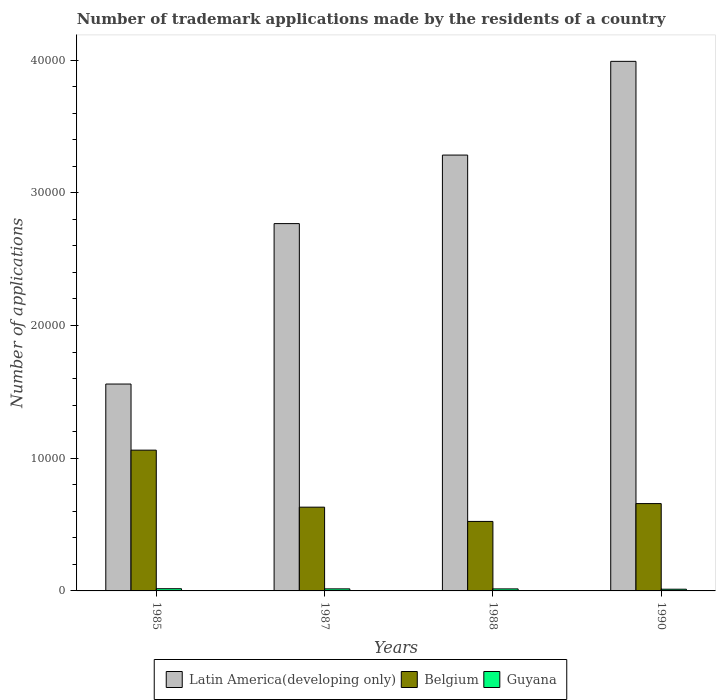Are the number of bars per tick equal to the number of legend labels?
Offer a terse response. Yes. What is the number of trademark applications made by the residents in Latin America(developing only) in 1987?
Your answer should be very brief. 2.77e+04. Across all years, what is the maximum number of trademark applications made by the residents in Latin America(developing only)?
Make the answer very short. 3.99e+04. Across all years, what is the minimum number of trademark applications made by the residents in Belgium?
Provide a short and direct response. 5237. What is the total number of trademark applications made by the residents in Guyana in the graph?
Your response must be concise. 602. What is the difference between the number of trademark applications made by the residents in Belgium in 1987 and that in 1990?
Offer a terse response. -269. What is the difference between the number of trademark applications made by the residents in Belgium in 1988 and the number of trademark applications made by the residents in Latin America(developing only) in 1987?
Offer a terse response. -2.24e+04. What is the average number of trademark applications made by the residents in Guyana per year?
Your answer should be very brief. 150.5. In the year 1990, what is the difference between the number of trademark applications made by the residents in Guyana and number of trademark applications made by the residents in Belgium?
Your response must be concise. -6452. What is the ratio of the number of trademark applications made by the residents in Latin America(developing only) in 1987 to that in 1990?
Provide a short and direct response. 0.69. Is the number of trademark applications made by the residents in Belgium in 1985 less than that in 1990?
Offer a very short reply. No. Is the difference between the number of trademark applications made by the residents in Guyana in 1987 and 1988 greater than the difference between the number of trademark applications made by the residents in Belgium in 1987 and 1988?
Your answer should be compact. No. What is the difference between the highest and the second highest number of trademark applications made by the residents in Latin America(developing only)?
Provide a short and direct response. 7062. What is the difference between the highest and the lowest number of trademark applications made by the residents in Latin America(developing only)?
Keep it short and to the point. 2.43e+04. What does the 3rd bar from the left in 1990 represents?
Your response must be concise. Guyana. What does the 1st bar from the right in 1988 represents?
Provide a succinct answer. Guyana. Is it the case that in every year, the sum of the number of trademark applications made by the residents in Latin America(developing only) and number of trademark applications made by the residents in Guyana is greater than the number of trademark applications made by the residents in Belgium?
Your answer should be very brief. Yes. Are all the bars in the graph horizontal?
Give a very brief answer. No. How many years are there in the graph?
Provide a short and direct response. 4. Are the values on the major ticks of Y-axis written in scientific E-notation?
Your response must be concise. No. How many legend labels are there?
Your answer should be very brief. 3. What is the title of the graph?
Your answer should be very brief. Number of trademark applications made by the residents of a country. Does "Timor-Leste" appear as one of the legend labels in the graph?
Offer a very short reply. No. What is the label or title of the X-axis?
Provide a succinct answer. Years. What is the label or title of the Y-axis?
Make the answer very short. Number of applications. What is the Number of applications of Latin America(developing only) in 1985?
Provide a short and direct response. 1.56e+04. What is the Number of applications in Belgium in 1985?
Ensure brevity in your answer.  1.06e+04. What is the Number of applications of Guyana in 1985?
Offer a very short reply. 166. What is the Number of applications of Latin America(developing only) in 1987?
Keep it short and to the point. 2.77e+04. What is the Number of applications in Belgium in 1987?
Keep it short and to the point. 6312. What is the Number of applications in Guyana in 1987?
Offer a terse response. 155. What is the Number of applications of Latin America(developing only) in 1988?
Your response must be concise. 3.28e+04. What is the Number of applications of Belgium in 1988?
Ensure brevity in your answer.  5237. What is the Number of applications in Guyana in 1988?
Make the answer very short. 152. What is the Number of applications in Latin America(developing only) in 1990?
Your response must be concise. 3.99e+04. What is the Number of applications in Belgium in 1990?
Ensure brevity in your answer.  6581. What is the Number of applications in Guyana in 1990?
Offer a terse response. 129. Across all years, what is the maximum Number of applications in Latin America(developing only)?
Provide a succinct answer. 3.99e+04. Across all years, what is the maximum Number of applications in Belgium?
Ensure brevity in your answer.  1.06e+04. Across all years, what is the maximum Number of applications of Guyana?
Keep it short and to the point. 166. Across all years, what is the minimum Number of applications in Latin America(developing only)?
Provide a succinct answer. 1.56e+04. Across all years, what is the minimum Number of applications of Belgium?
Offer a terse response. 5237. Across all years, what is the minimum Number of applications of Guyana?
Give a very brief answer. 129. What is the total Number of applications in Latin America(developing only) in the graph?
Your response must be concise. 1.16e+05. What is the total Number of applications of Belgium in the graph?
Give a very brief answer. 2.87e+04. What is the total Number of applications of Guyana in the graph?
Provide a short and direct response. 602. What is the difference between the Number of applications in Latin America(developing only) in 1985 and that in 1987?
Offer a very short reply. -1.21e+04. What is the difference between the Number of applications of Belgium in 1985 and that in 1987?
Your answer should be compact. 4296. What is the difference between the Number of applications of Latin America(developing only) in 1985 and that in 1988?
Provide a short and direct response. -1.73e+04. What is the difference between the Number of applications in Belgium in 1985 and that in 1988?
Make the answer very short. 5371. What is the difference between the Number of applications in Latin America(developing only) in 1985 and that in 1990?
Your answer should be compact. -2.43e+04. What is the difference between the Number of applications in Belgium in 1985 and that in 1990?
Provide a succinct answer. 4027. What is the difference between the Number of applications of Latin America(developing only) in 1987 and that in 1988?
Keep it short and to the point. -5165. What is the difference between the Number of applications in Belgium in 1987 and that in 1988?
Offer a very short reply. 1075. What is the difference between the Number of applications in Latin America(developing only) in 1987 and that in 1990?
Give a very brief answer. -1.22e+04. What is the difference between the Number of applications in Belgium in 1987 and that in 1990?
Your response must be concise. -269. What is the difference between the Number of applications in Latin America(developing only) in 1988 and that in 1990?
Provide a short and direct response. -7062. What is the difference between the Number of applications in Belgium in 1988 and that in 1990?
Offer a terse response. -1344. What is the difference between the Number of applications of Latin America(developing only) in 1985 and the Number of applications of Belgium in 1987?
Ensure brevity in your answer.  9278. What is the difference between the Number of applications in Latin America(developing only) in 1985 and the Number of applications in Guyana in 1987?
Provide a short and direct response. 1.54e+04. What is the difference between the Number of applications in Belgium in 1985 and the Number of applications in Guyana in 1987?
Ensure brevity in your answer.  1.05e+04. What is the difference between the Number of applications in Latin America(developing only) in 1985 and the Number of applications in Belgium in 1988?
Your answer should be very brief. 1.04e+04. What is the difference between the Number of applications of Latin America(developing only) in 1985 and the Number of applications of Guyana in 1988?
Give a very brief answer. 1.54e+04. What is the difference between the Number of applications of Belgium in 1985 and the Number of applications of Guyana in 1988?
Make the answer very short. 1.05e+04. What is the difference between the Number of applications of Latin America(developing only) in 1985 and the Number of applications of Belgium in 1990?
Ensure brevity in your answer.  9009. What is the difference between the Number of applications in Latin America(developing only) in 1985 and the Number of applications in Guyana in 1990?
Your answer should be very brief. 1.55e+04. What is the difference between the Number of applications of Belgium in 1985 and the Number of applications of Guyana in 1990?
Give a very brief answer. 1.05e+04. What is the difference between the Number of applications in Latin America(developing only) in 1987 and the Number of applications in Belgium in 1988?
Give a very brief answer. 2.24e+04. What is the difference between the Number of applications of Latin America(developing only) in 1987 and the Number of applications of Guyana in 1988?
Your response must be concise. 2.75e+04. What is the difference between the Number of applications in Belgium in 1987 and the Number of applications in Guyana in 1988?
Ensure brevity in your answer.  6160. What is the difference between the Number of applications of Latin America(developing only) in 1987 and the Number of applications of Belgium in 1990?
Make the answer very short. 2.11e+04. What is the difference between the Number of applications in Latin America(developing only) in 1987 and the Number of applications in Guyana in 1990?
Ensure brevity in your answer.  2.76e+04. What is the difference between the Number of applications in Belgium in 1987 and the Number of applications in Guyana in 1990?
Offer a very short reply. 6183. What is the difference between the Number of applications of Latin America(developing only) in 1988 and the Number of applications of Belgium in 1990?
Offer a terse response. 2.63e+04. What is the difference between the Number of applications in Latin America(developing only) in 1988 and the Number of applications in Guyana in 1990?
Ensure brevity in your answer.  3.27e+04. What is the difference between the Number of applications of Belgium in 1988 and the Number of applications of Guyana in 1990?
Offer a very short reply. 5108. What is the average Number of applications in Latin America(developing only) per year?
Offer a very short reply. 2.90e+04. What is the average Number of applications of Belgium per year?
Your answer should be very brief. 7184.5. What is the average Number of applications of Guyana per year?
Your answer should be very brief. 150.5. In the year 1985, what is the difference between the Number of applications in Latin America(developing only) and Number of applications in Belgium?
Make the answer very short. 4982. In the year 1985, what is the difference between the Number of applications in Latin America(developing only) and Number of applications in Guyana?
Keep it short and to the point. 1.54e+04. In the year 1985, what is the difference between the Number of applications in Belgium and Number of applications in Guyana?
Provide a succinct answer. 1.04e+04. In the year 1987, what is the difference between the Number of applications of Latin America(developing only) and Number of applications of Belgium?
Provide a short and direct response. 2.14e+04. In the year 1987, what is the difference between the Number of applications in Latin America(developing only) and Number of applications in Guyana?
Your answer should be compact. 2.75e+04. In the year 1987, what is the difference between the Number of applications in Belgium and Number of applications in Guyana?
Provide a succinct answer. 6157. In the year 1988, what is the difference between the Number of applications in Latin America(developing only) and Number of applications in Belgium?
Provide a short and direct response. 2.76e+04. In the year 1988, what is the difference between the Number of applications in Latin America(developing only) and Number of applications in Guyana?
Give a very brief answer. 3.27e+04. In the year 1988, what is the difference between the Number of applications in Belgium and Number of applications in Guyana?
Make the answer very short. 5085. In the year 1990, what is the difference between the Number of applications in Latin America(developing only) and Number of applications in Belgium?
Your answer should be very brief. 3.33e+04. In the year 1990, what is the difference between the Number of applications in Latin America(developing only) and Number of applications in Guyana?
Provide a succinct answer. 3.98e+04. In the year 1990, what is the difference between the Number of applications of Belgium and Number of applications of Guyana?
Provide a short and direct response. 6452. What is the ratio of the Number of applications in Latin America(developing only) in 1985 to that in 1987?
Give a very brief answer. 0.56. What is the ratio of the Number of applications in Belgium in 1985 to that in 1987?
Your response must be concise. 1.68. What is the ratio of the Number of applications of Guyana in 1985 to that in 1987?
Keep it short and to the point. 1.07. What is the ratio of the Number of applications in Latin America(developing only) in 1985 to that in 1988?
Your response must be concise. 0.47. What is the ratio of the Number of applications in Belgium in 1985 to that in 1988?
Your answer should be compact. 2.03. What is the ratio of the Number of applications of Guyana in 1985 to that in 1988?
Your answer should be compact. 1.09. What is the ratio of the Number of applications in Latin America(developing only) in 1985 to that in 1990?
Ensure brevity in your answer.  0.39. What is the ratio of the Number of applications of Belgium in 1985 to that in 1990?
Offer a terse response. 1.61. What is the ratio of the Number of applications of Guyana in 1985 to that in 1990?
Your response must be concise. 1.29. What is the ratio of the Number of applications of Latin America(developing only) in 1987 to that in 1988?
Offer a very short reply. 0.84. What is the ratio of the Number of applications in Belgium in 1987 to that in 1988?
Your response must be concise. 1.21. What is the ratio of the Number of applications in Guyana in 1987 to that in 1988?
Make the answer very short. 1.02. What is the ratio of the Number of applications in Latin America(developing only) in 1987 to that in 1990?
Your response must be concise. 0.69. What is the ratio of the Number of applications in Belgium in 1987 to that in 1990?
Your answer should be very brief. 0.96. What is the ratio of the Number of applications in Guyana in 1987 to that in 1990?
Give a very brief answer. 1.2. What is the ratio of the Number of applications in Latin America(developing only) in 1988 to that in 1990?
Your response must be concise. 0.82. What is the ratio of the Number of applications in Belgium in 1988 to that in 1990?
Make the answer very short. 0.8. What is the ratio of the Number of applications of Guyana in 1988 to that in 1990?
Give a very brief answer. 1.18. What is the difference between the highest and the second highest Number of applications in Latin America(developing only)?
Provide a short and direct response. 7062. What is the difference between the highest and the second highest Number of applications in Belgium?
Keep it short and to the point. 4027. What is the difference between the highest and the lowest Number of applications in Latin America(developing only)?
Your response must be concise. 2.43e+04. What is the difference between the highest and the lowest Number of applications of Belgium?
Offer a very short reply. 5371. What is the difference between the highest and the lowest Number of applications in Guyana?
Make the answer very short. 37. 